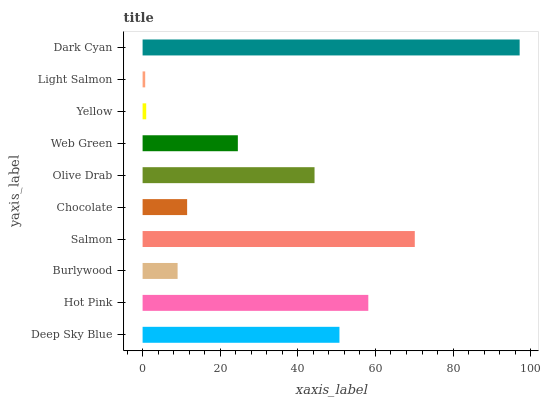Is Light Salmon the minimum?
Answer yes or no. Yes. Is Dark Cyan the maximum?
Answer yes or no. Yes. Is Hot Pink the minimum?
Answer yes or no. No. Is Hot Pink the maximum?
Answer yes or no. No. Is Hot Pink greater than Deep Sky Blue?
Answer yes or no. Yes. Is Deep Sky Blue less than Hot Pink?
Answer yes or no. Yes. Is Deep Sky Blue greater than Hot Pink?
Answer yes or no. No. Is Hot Pink less than Deep Sky Blue?
Answer yes or no. No. Is Olive Drab the high median?
Answer yes or no. Yes. Is Web Green the low median?
Answer yes or no. Yes. Is Chocolate the high median?
Answer yes or no. No. Is Deep Sky Blue the low median?
Answer yes or no. No. 